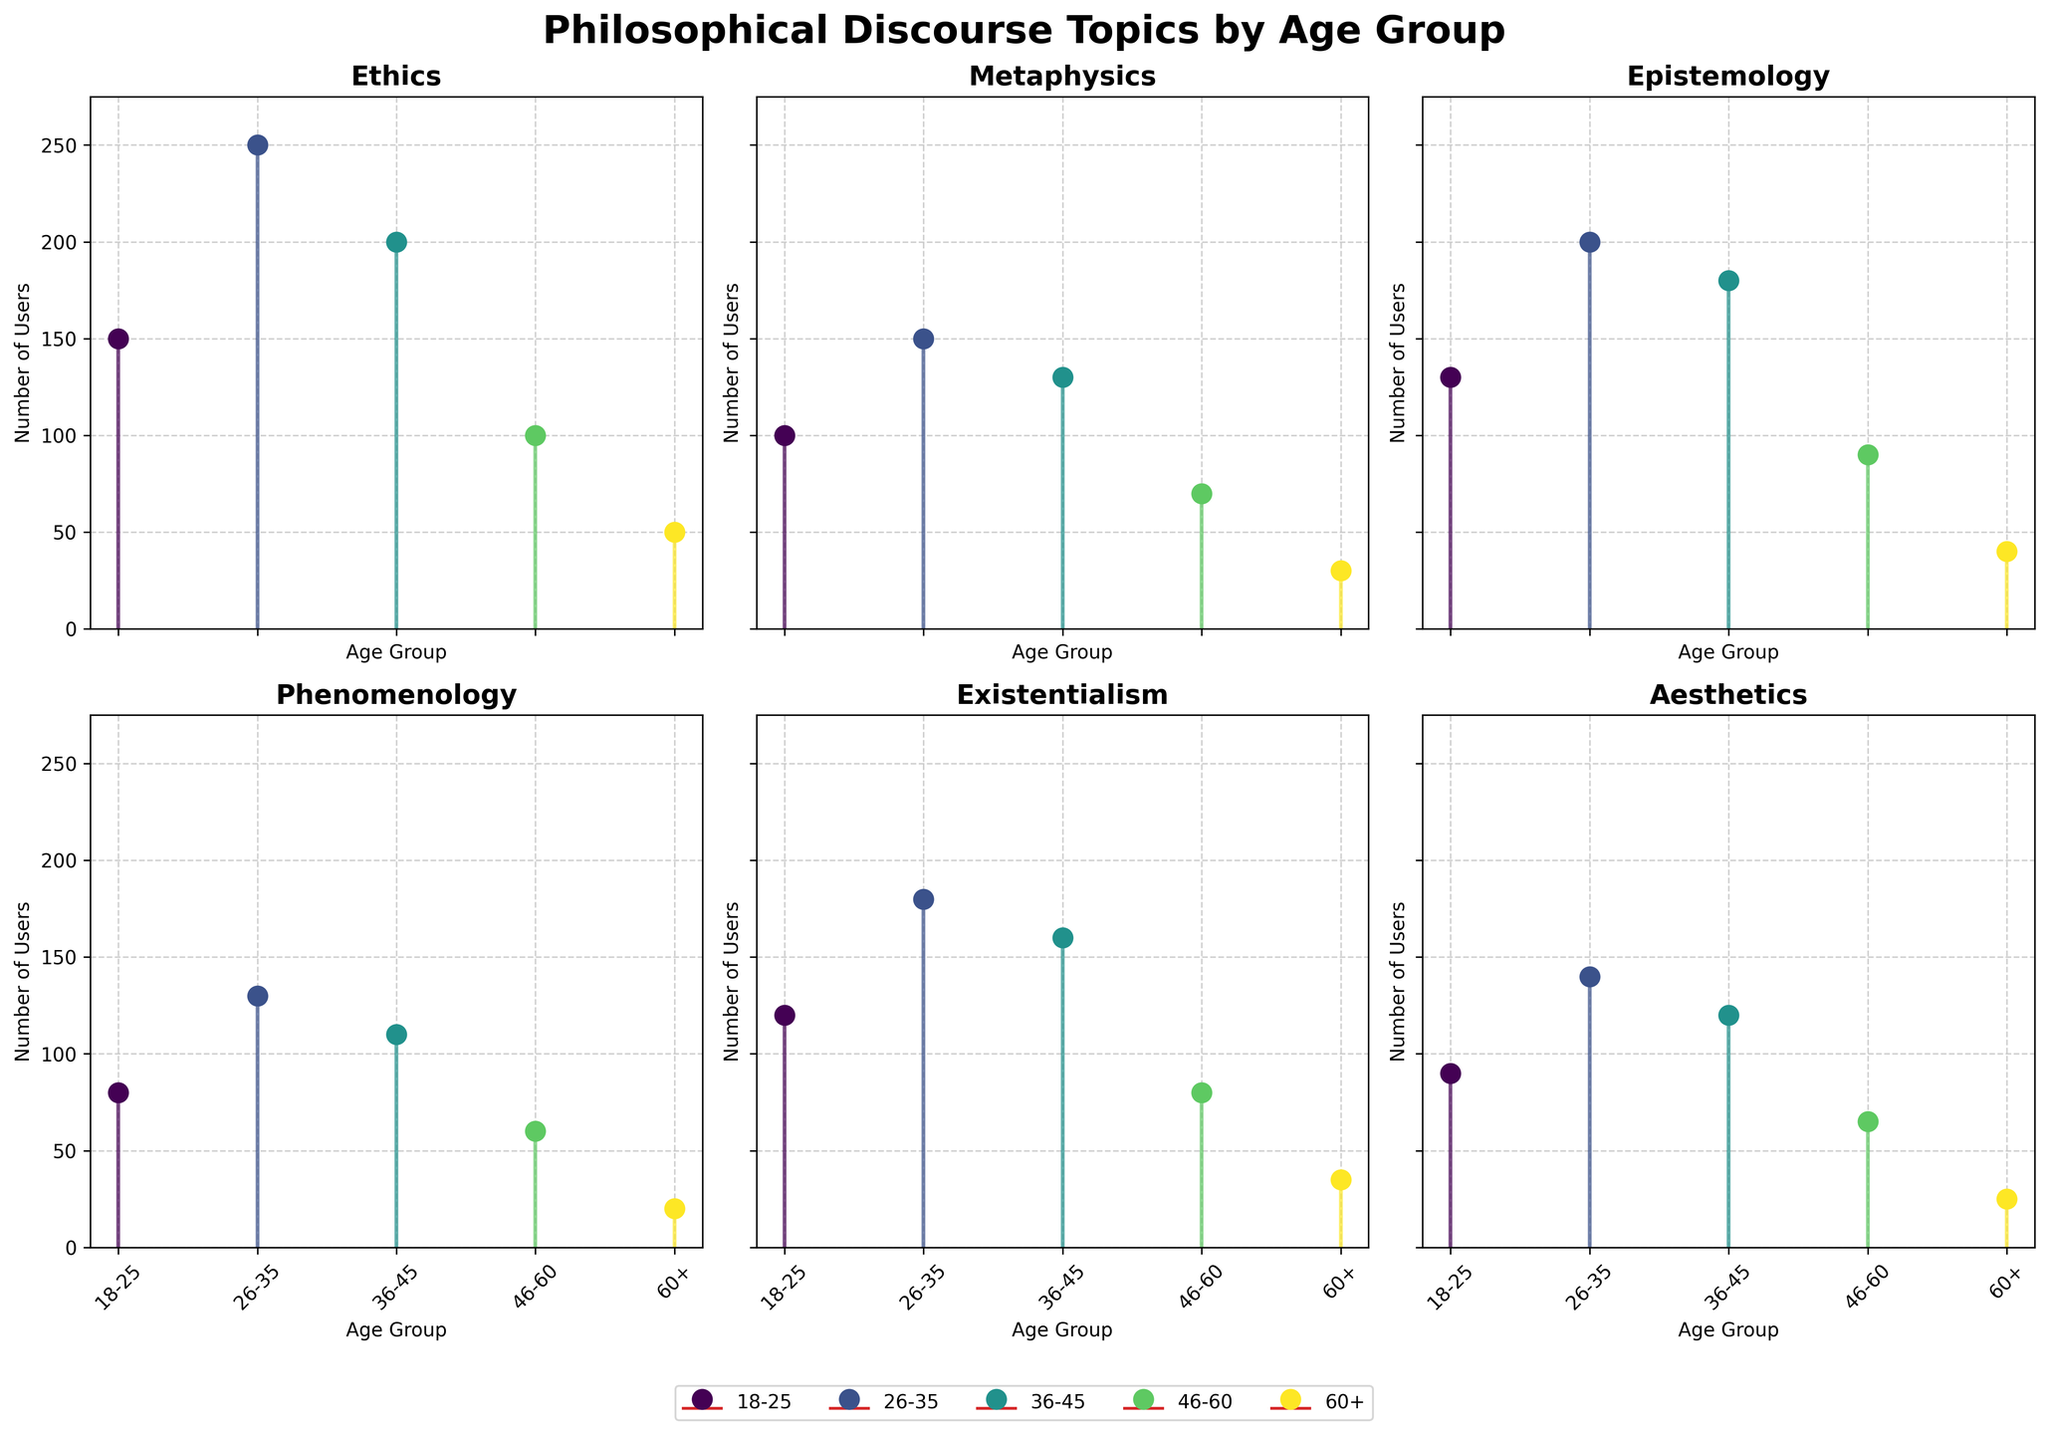What's the title of the figure? The title typically appears at the top of the figure. From the code, we know the title is set as "Philosophical Discourse Topics by Age Group".
Answer: Philosophical Discourse Topics by Age Group Which age group has the highest number of users discussing "Ethics"? By comparing the stem plots for "Ethics", we observe the highest peak among the age groups. The age group with the tall stem (the highest value) for "Ethics" is 26-35.
Answer: 26-35 What is the number of users discussing "Epistemology" in the 46-60 age group? Locate the stem for "Epistemology" corresponding to the 46-60 age group. The value is visibly marked or reaches a specific height on the plot. The number indicated is 90.
Answer: 90 For "Existentialism," which age group has fewer users, 18-25 or 36-45? Compare the stem heights for the 18-25 and 36-45 age groups in the "Existentialism" subplot. The 18-25 age group has a lower stem height relative to the 36-45 age group.
Answer: 18-25 What’s the combined number of users discussing "Metaphysics" in the age groups 26-35 and 60+? First, find the values for 26-35 and 60+ age groups in the "Metaphysics" subplot. The values are 150 and 30 respectively. Add these two values together: 150 + 30 = 180.
Answer: 180 Relative to "Aesthetics," which age group has the smallest interest, and what is the number of users? In the "Aesthetics" subplot, the age group with the shortest stem corresponds to the smallest number of users. The 60+ age group has the smallest height, with 25 users.
Answer: 60+, 25 Based on the subplots, in which topic does the 18-25 age group show the least interest? Compare the heights of the stems for the 18-25 age group across all subplots. The shortest stem for this age group appears in the "Phenomenology" subplot.
Answer: Phenomenology How many more users in the 36-45 age group discuss "Ethics" compared to "Metaphysics"? Identify the user counts in the 36-45 age group for both "Ethics" and "Metaphysics". For "Ethics", the value is 200, and for "Metaphysics", it is 130. Subtract the smaller number from the larger: 200 - 130 = 70.
Answer: 70 Rank the age groups in descending order of their interest in "Phenomenology." Observe the stem heights for "Phenomenology" and list the age groups in order of their stem height from tallest to shortest: 26-35, 36-45, 18-25, 46-60, 60+.
Answer: 26-35, 36-45, 18-25, 46-60, 60+ What’s the average number of users discussing "Existentialism" across all age groups? To find the average, sum the number of users for "Existentialism" across all age groups (120 +180 + 160 + 80 + 35) = 575. Divide this sum by the number of age groups (5): 575 / 5 = 115.
Answer: 115 